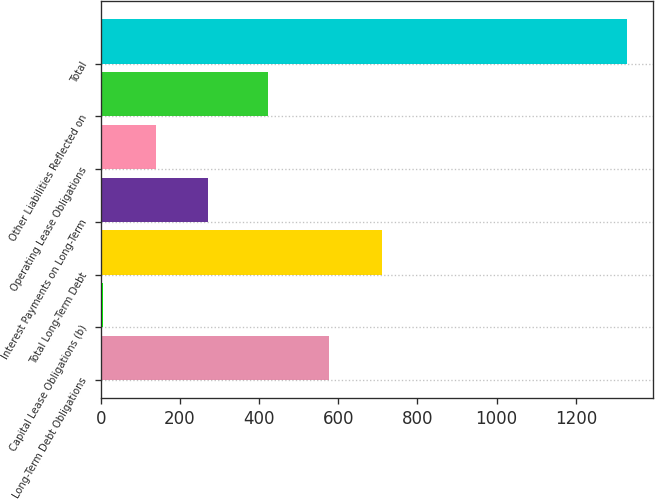<chart> <loc_0><loc_0><loc_500><loc_500><bar_chart><fcel>Long-Term Debt Obligations<fcel>Capital Lease Obligations (b)<fcel>Total Long-Term Debt<fcel>Interest Payments on Long-Term<fcel>Operating Lease Obligations<fcel>Other Liabilities Reflected on<fcel>Total<nl><fcel>577<fcel>6.1<fcel>709.35<fcel>270.8<fcel>138.45<fcel>423.3<fcel>1329.6<nl></chart> 